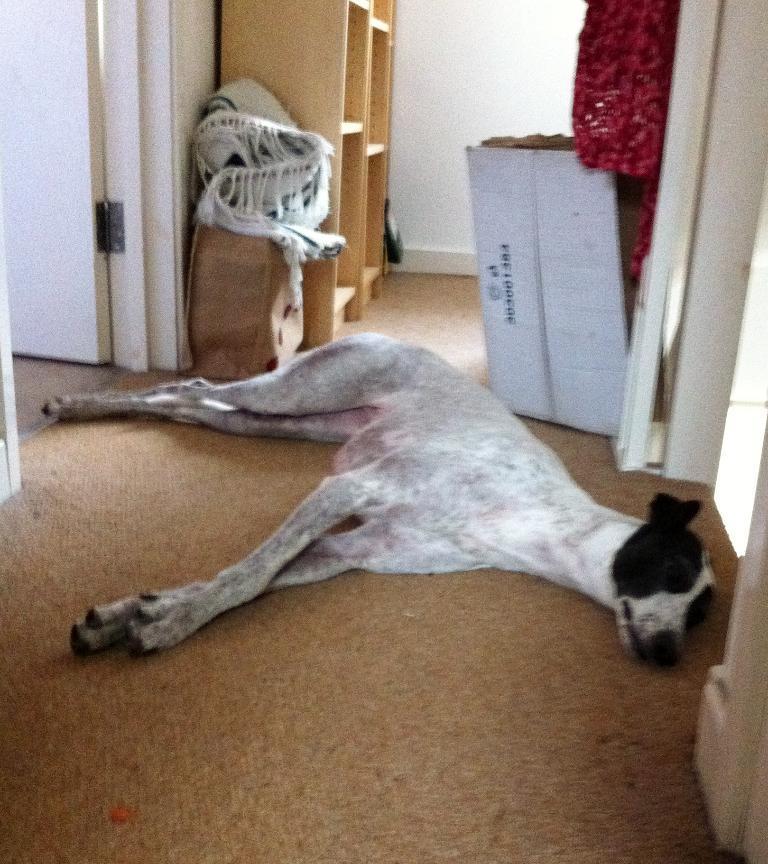In one or two sentences, can you explain what this image depicts? In this image we can see a dog lying on the floor, cupboards, doors, blankets and cardboard cartons. 